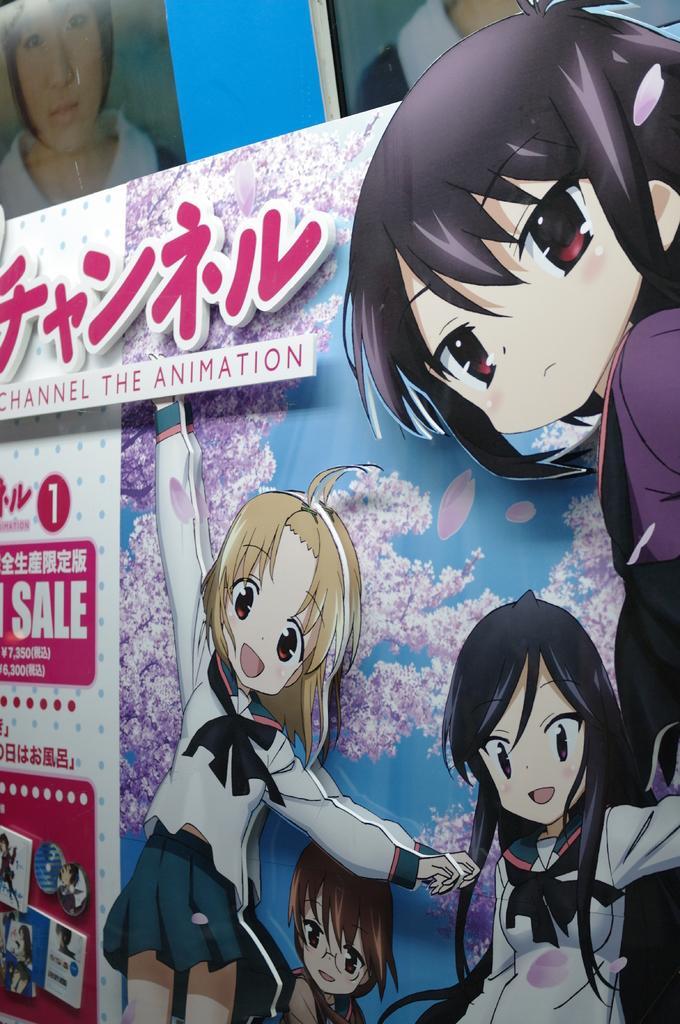How would you summarize this image in a sentence or two? There is a poster with images of animated characters. Also something is written on that. In the back there are photos of some people. 